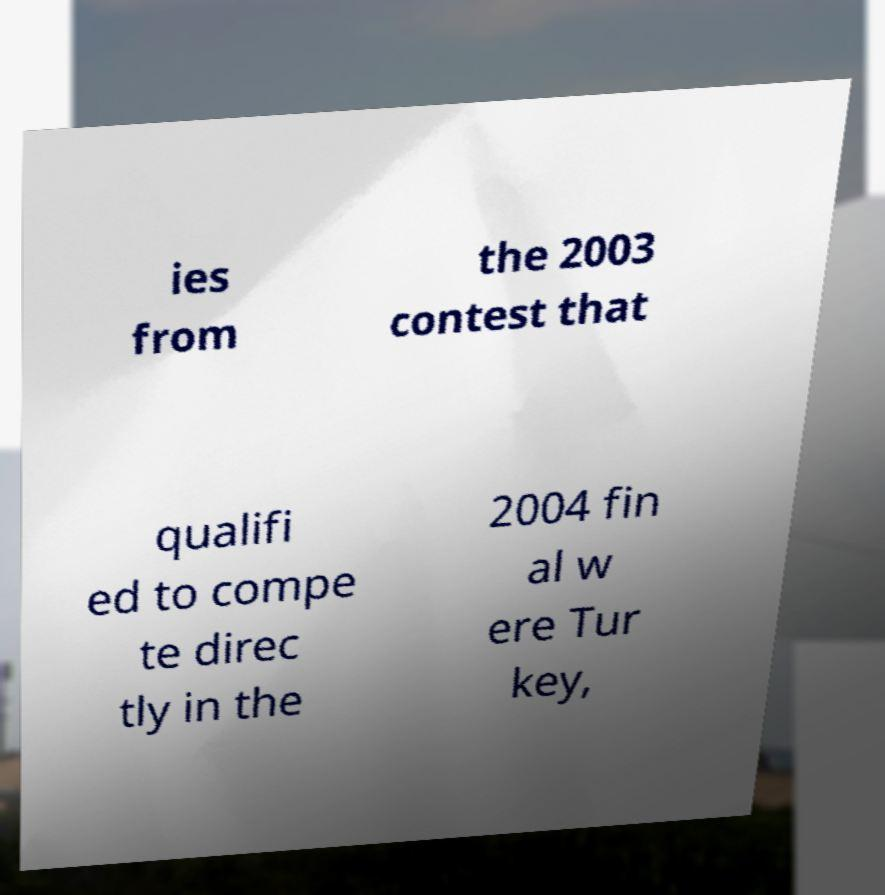Could you assist in decoding the text presented in this image and type it out clearly? ies from the 2003 contest that qualifi ed to compe te direc tly in the 2004 fin al w ere Tur key, 